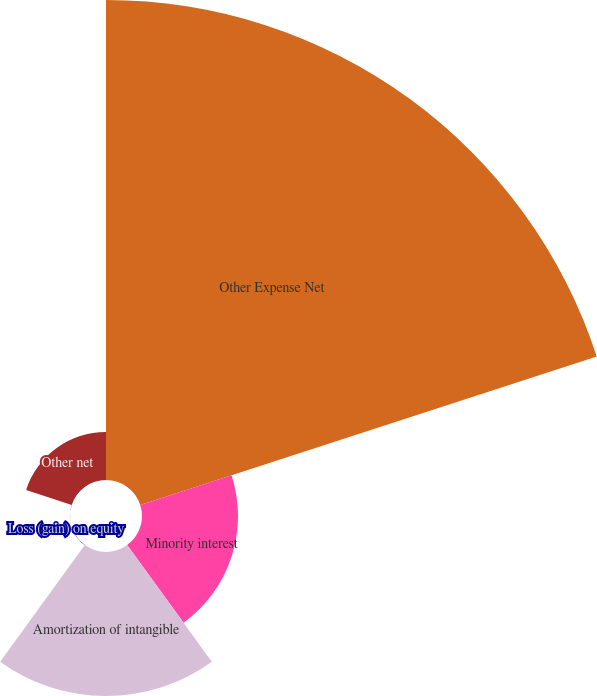<chart> <loc_0><loc_0><loc_500><loc_500><pie_chart><fcel>Other Expense Net<fcel>Minority interest<fcel>Amortization of intangible<fcel>Loss (gain) on equity<fcel>Other net<nl><fcel>62.49%<fcel>12.5%<fcel>18.75%<fcel>0.01%<fcel>6.25%<nl></chart> 